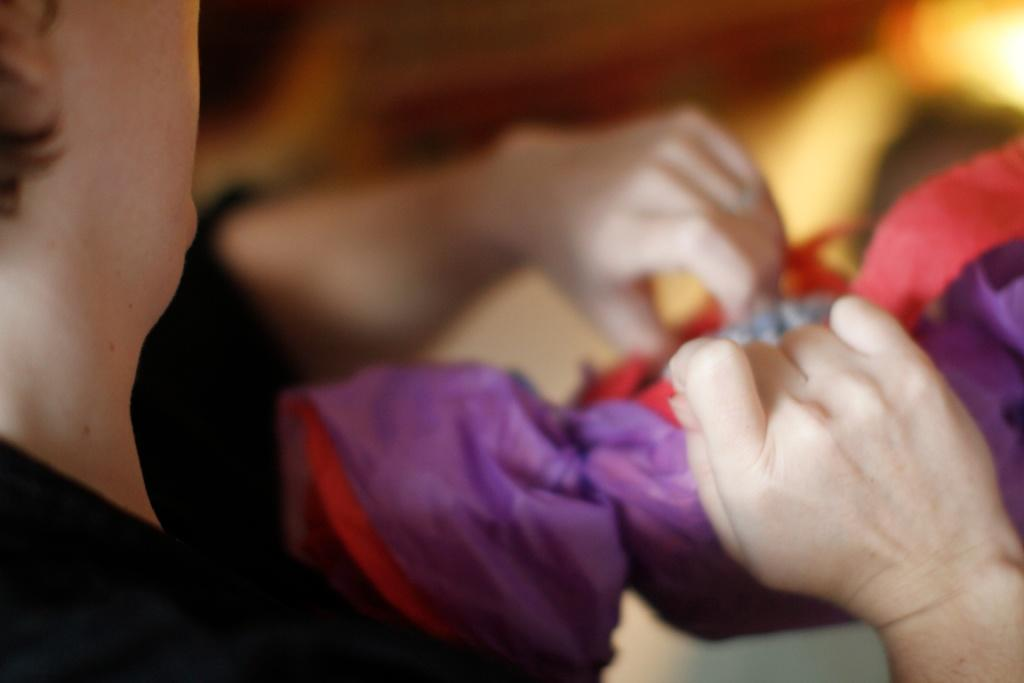What is present in the image? There is a person in the image. What is the person doing in the image? The person is holding an object with both hands. What is the purpose of the jelly in the image? There is no jelly present in the image, so it cannot be used to determine its purpose. 